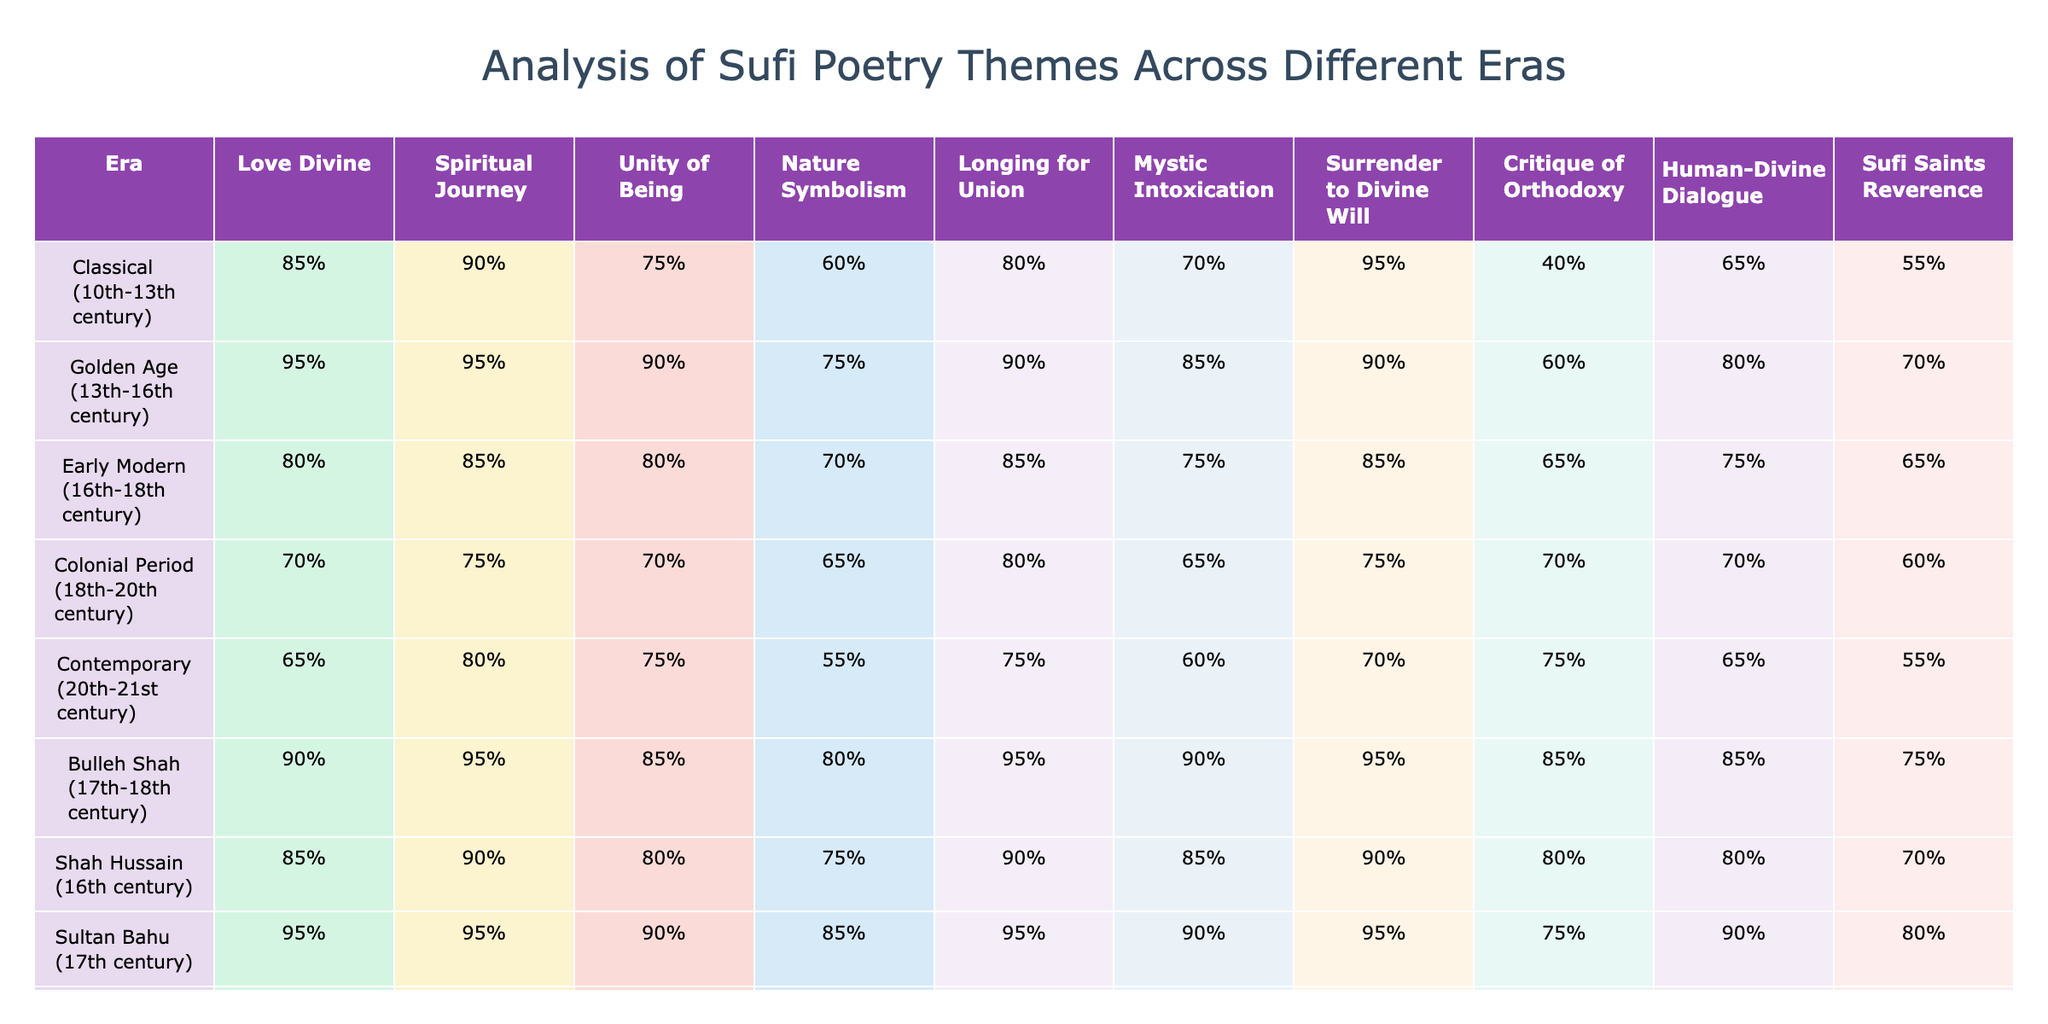What era has the highest percentage of "Love Divine"? By examining the values in the "Love Divine" column across all eras, the Classical era shows a percentage of 85%, while the Golden Age has the highest at 95%.
Answer: 95% Which Sufi poet from the table had the lowest score in "Human-Divine Dialogue"? The last column indicates the scores for "Human-Divine Dialogue", and by comparing them, Baba Farid has the lowest score at 75%.
Answer: 75% What is the percentage difference in "Spiritual Journey" between the Golden Age and the Colonial Period? The Golden Age has a score of 95% for "Spiritual Journey," while the Colonial Period has 75%. The difference is 95% - 75% = 20%.
Answer: 20% Is "Nature Symbolism" consistently high in the Classical and Golden Age eras? In the table, the Classical era has a score of 60% and the Golden Age has 75%, so "Nature Symbolism" is higher in the Golden Age but not consistently high when comparing both eras.
Answer: No What is the average percentage of "Longing for Union" across all eras? Adding the values of "Longing for Union" (80%, 90%, 85%, 80%, 75%, 95%, 90%, 85%, 85%, 90%) gives 880%. With 10 data points, the average is 880% / 10 = 88%.
Answer: 88% In which era is "Mystic Intoxication" the highest, and what is the percentage? The "Mystic Intoxication" column shows the highest percentage in the Bulleh Shah era at 90%.
Answer: 90% Does the Colonial Period exhibit a lower interest in "Critique of Orthodoxy" compared to the Early Modern era? The Colonial Period has a score of 70% for "Critique of Orthodoxy," while the Early Modern era has 65%. So, it shows a slightly higher interest in the Colonial Period.
Answer: Yes Which theme has the lowest overall interest in the Contemporary era? By reviewing the scores in the Contemporary era, the lowest score is "Nature Symbolism" at 55%.
Answer: 55% Comparing all poets, who has the highest percentage for "Surrender to Divine Will"? Sultan Bahu and Bulleh Shah both have a score of 95% for "Surrender to Divine Will", making them the highest.
Answer: 95% What can be said about the trend of "Unity of Being" from the Classical to the Contemporary era? The percentages show a decrease from 90% in the Classical era to 75% in the Contemporary era, indicating a downward trend in "Unity of Being" appreciation.
Answer: Downward trend 